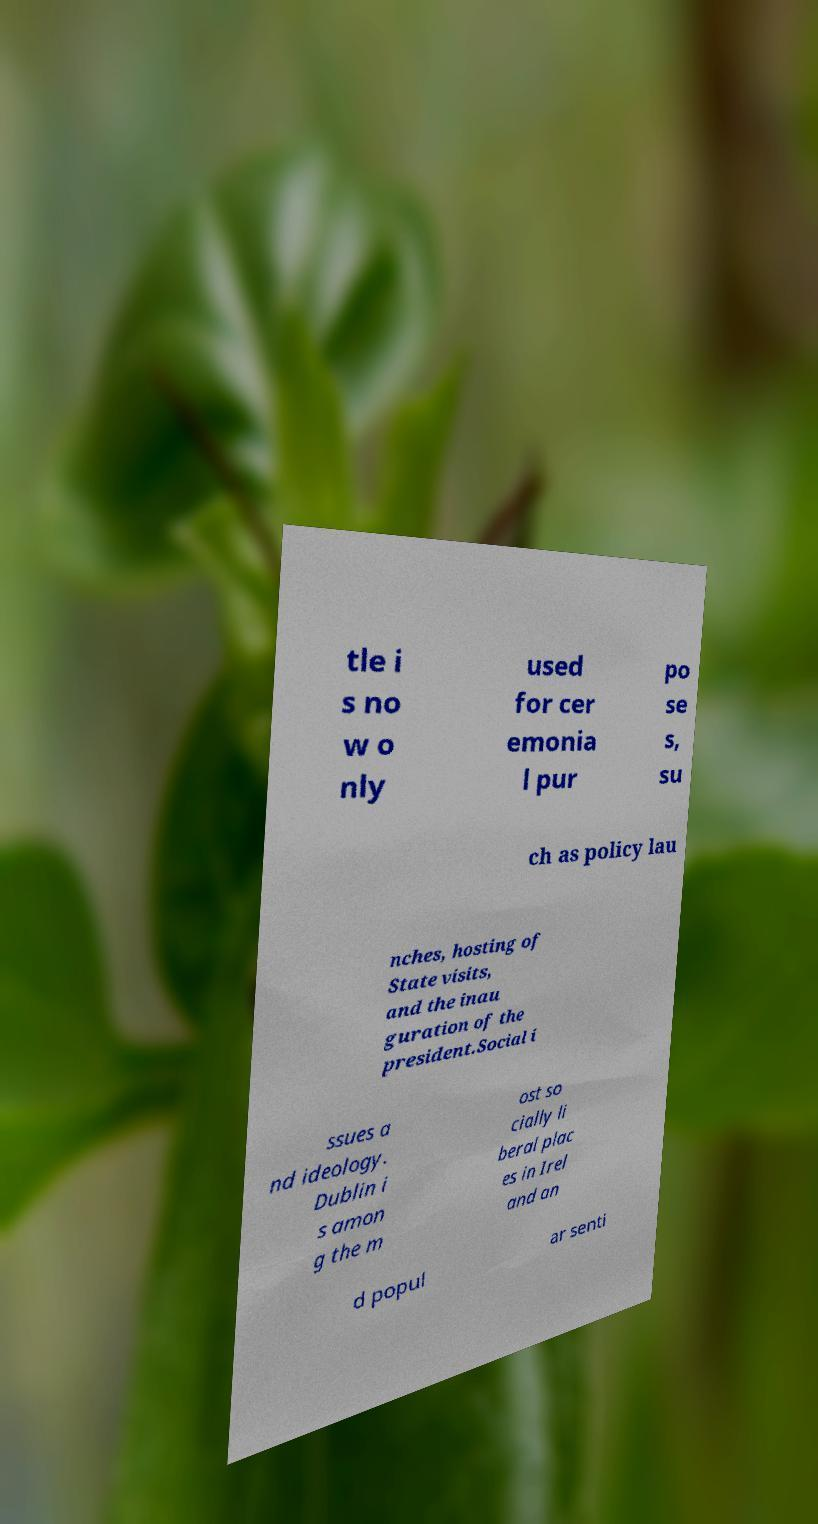Can you accurately transcribe the text from the provided image for me? tle i s no w o nly used for cer emonia l pur po se s, su ch as policy lau nches, hosting of State visits, and the inau guration of the president.Social i ssues a nd ideology. Dublin i s amon g the m ost so cially li beral plac es in Irel and an d popul ar senti 